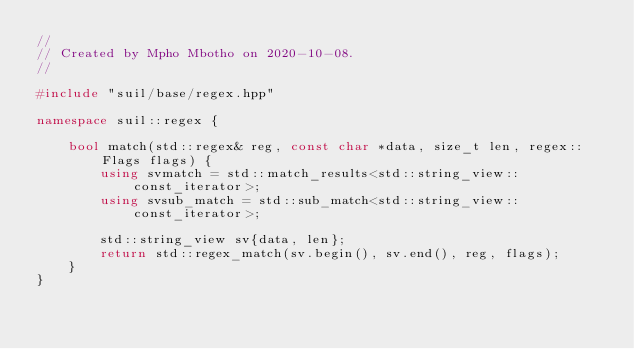<code> <loc_0><loc_0><loc_500><loc_500><_C++_>//
// Created by Mpho Mbotho on 2020-10-08.
//

#include "suil/base/regex.hpp"

namespace suil::regex {

    bool match(std::regex& reg, const char *data, size_t len, regex::Flags flags) {
        using svmatch = std::match_results<std::string_view::const_iterator>;
        using svsub_match = std::sub_match<std::string_view::const_iterator>;

        std::string_view sv{data, len};
        return std::regex_match(sv.begin(), sv.end(), reg, flags);
    }
}</code> 